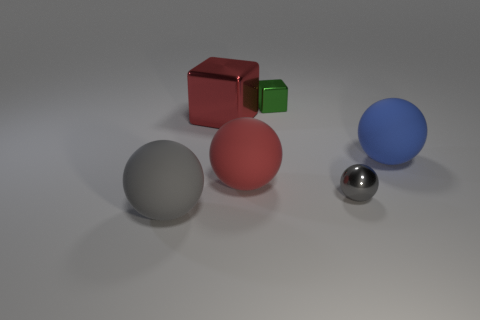How are the objects positioned in relation to each other? In the image, the objects are spaced evenly on a flat surface, suggesting intentional placement. The two cubes are positioned close to each other, with the green one slightly in front of the red, indicating depth. The spheres are spread out, with the gray one to the left, the red one in the center, and the blue one to the right, creating a diagonal line that leads the eye across the image. The small silver sphere sits in the foreground, again adding depth to the scene. 